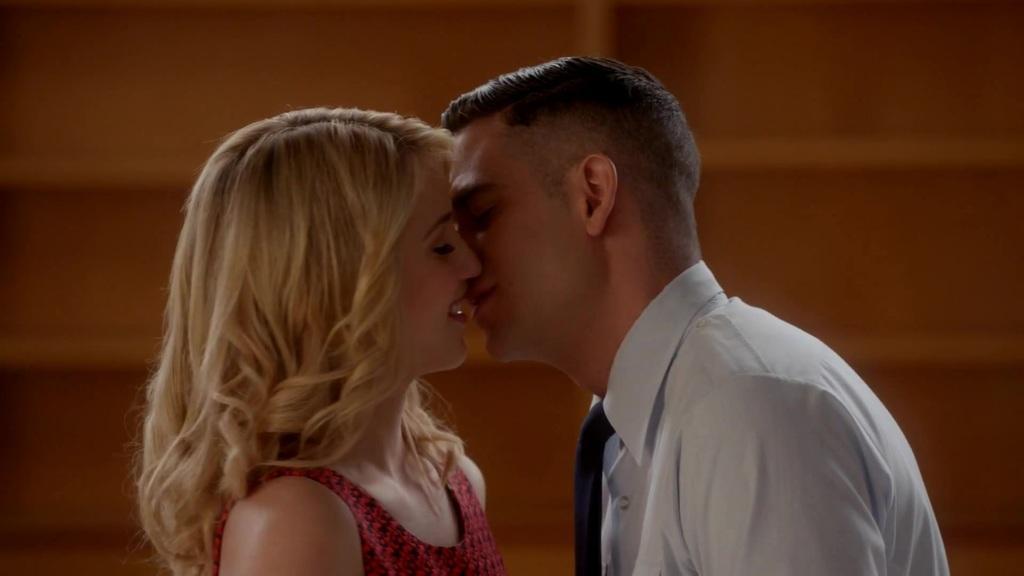Could you give a brief overview of what you see in this image? In this image we can see a two persons are kissing each other. 